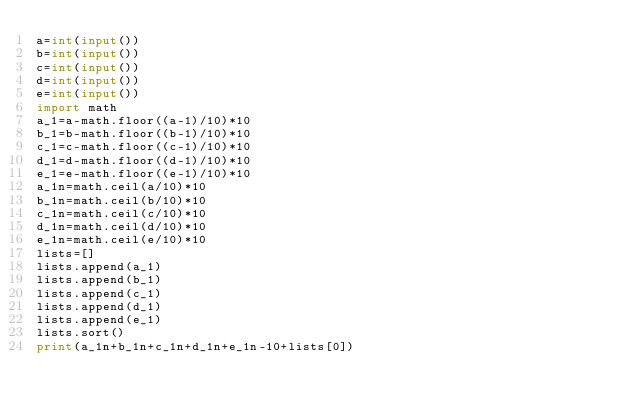<code> <loc_0><loc_0><loc_500><loc_500><_Python_>a=int(input())
b=int(input())
c=int(input())
d=int(input())
e=int(input())
import math
a_1=a-math.floor((a-1)/10)*10
b_1=b-math.floor((b-1)/10)*10
c_1=c-math.floor((c-1)/10)*10
d_1=d-math.floor((d-1)/10)*10
e_1=e-math.floor((e-1)/10)*10
a_1n=math.ceil(a/10)*10
b_1n=math.ceil(b/10)*10
c_1n=math.ceil(c/10)*10
d_1n=math.ceil(d/10)*10
e_1n=math.ceil(e/10)*10
lists=[]
lists.append(a_1)
lists.append(b_1)
lists.append(c_1)
lists.append(d_1)
lists.append(e_1)
lists.sort()
print(a_1n+b_1n+c_1n+d_1n+e_1n-10+lists[0])</code> 